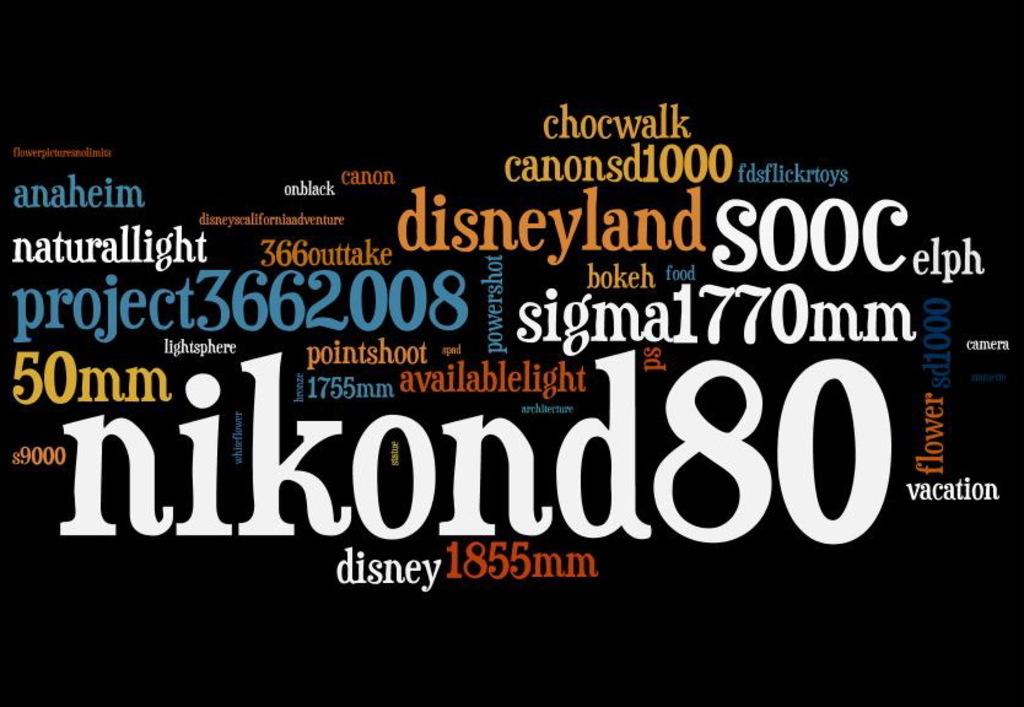What is the nikon camera model?
Give a very brief answer. D80. What word is at the top in yellow?
Offer a very short reply. Chocwalk. 